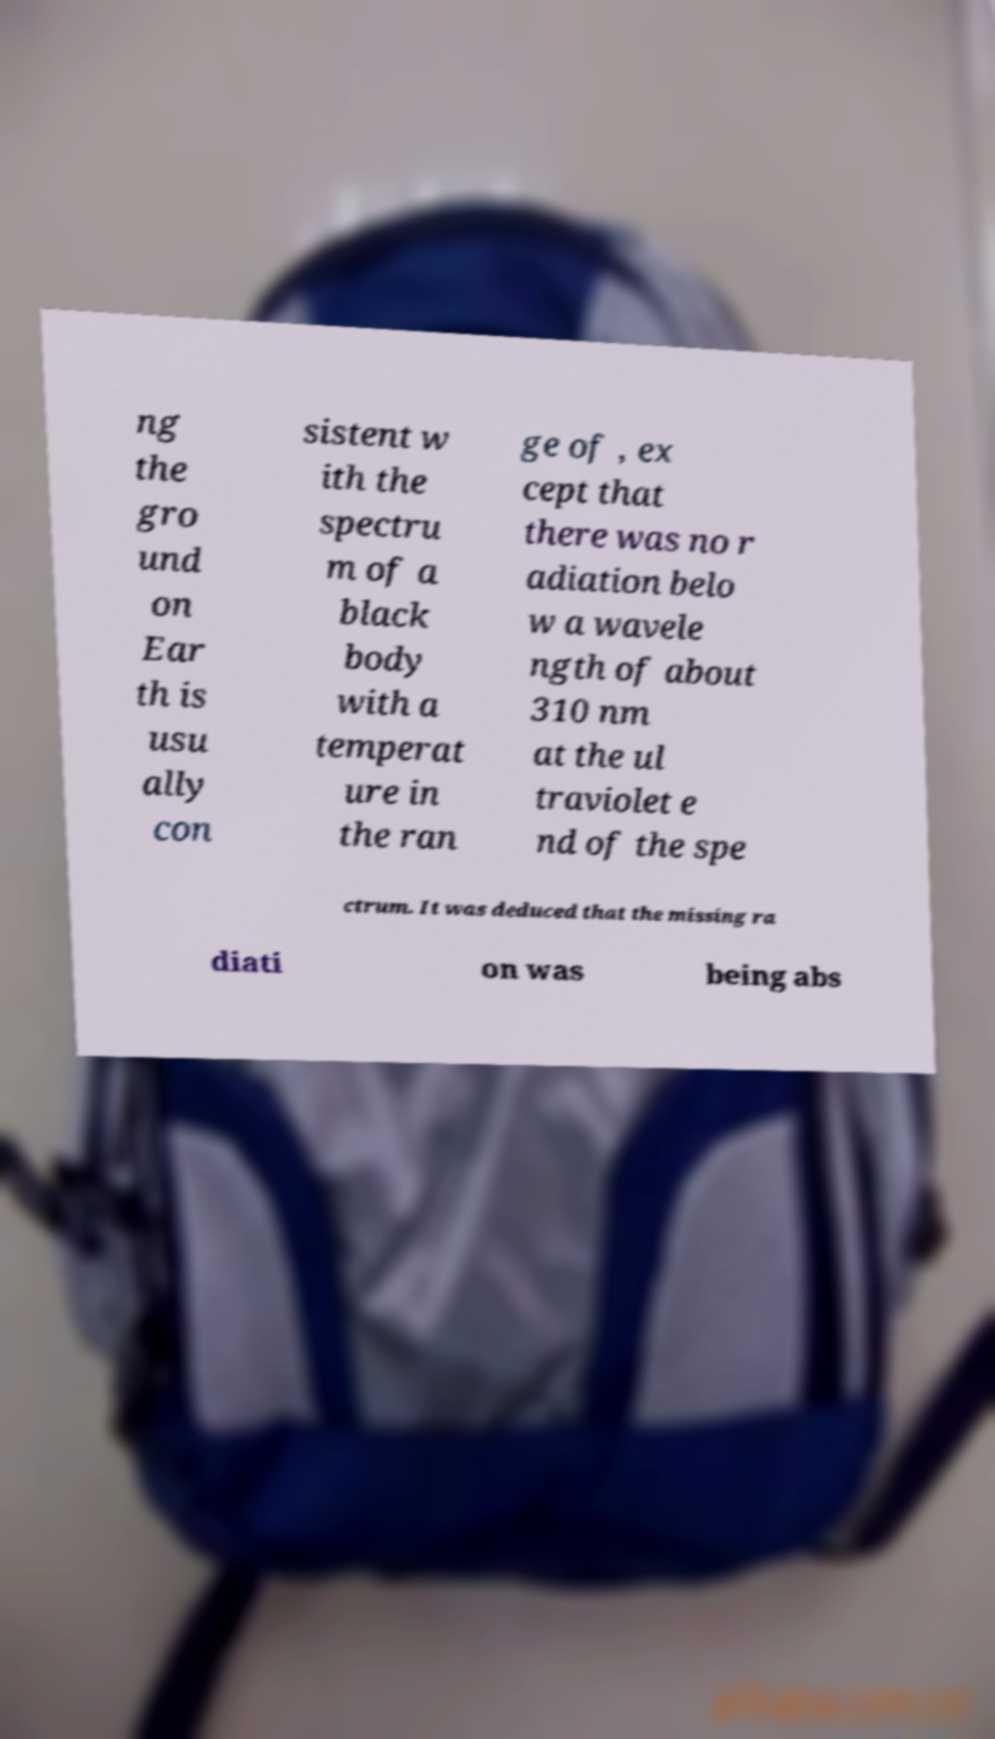Could you extract and type out the text from this image? ng the gro und on Ear th is usu ally con sistent w ith the spectru m of a black body with a temperat ure in the ran ge of , ex cept that there was no r adiation belo w a wavele ngth of about 310 nm at the ul traviolet e nd of the spe ctrum. It was deduced that the missing ra diati on was being abs 